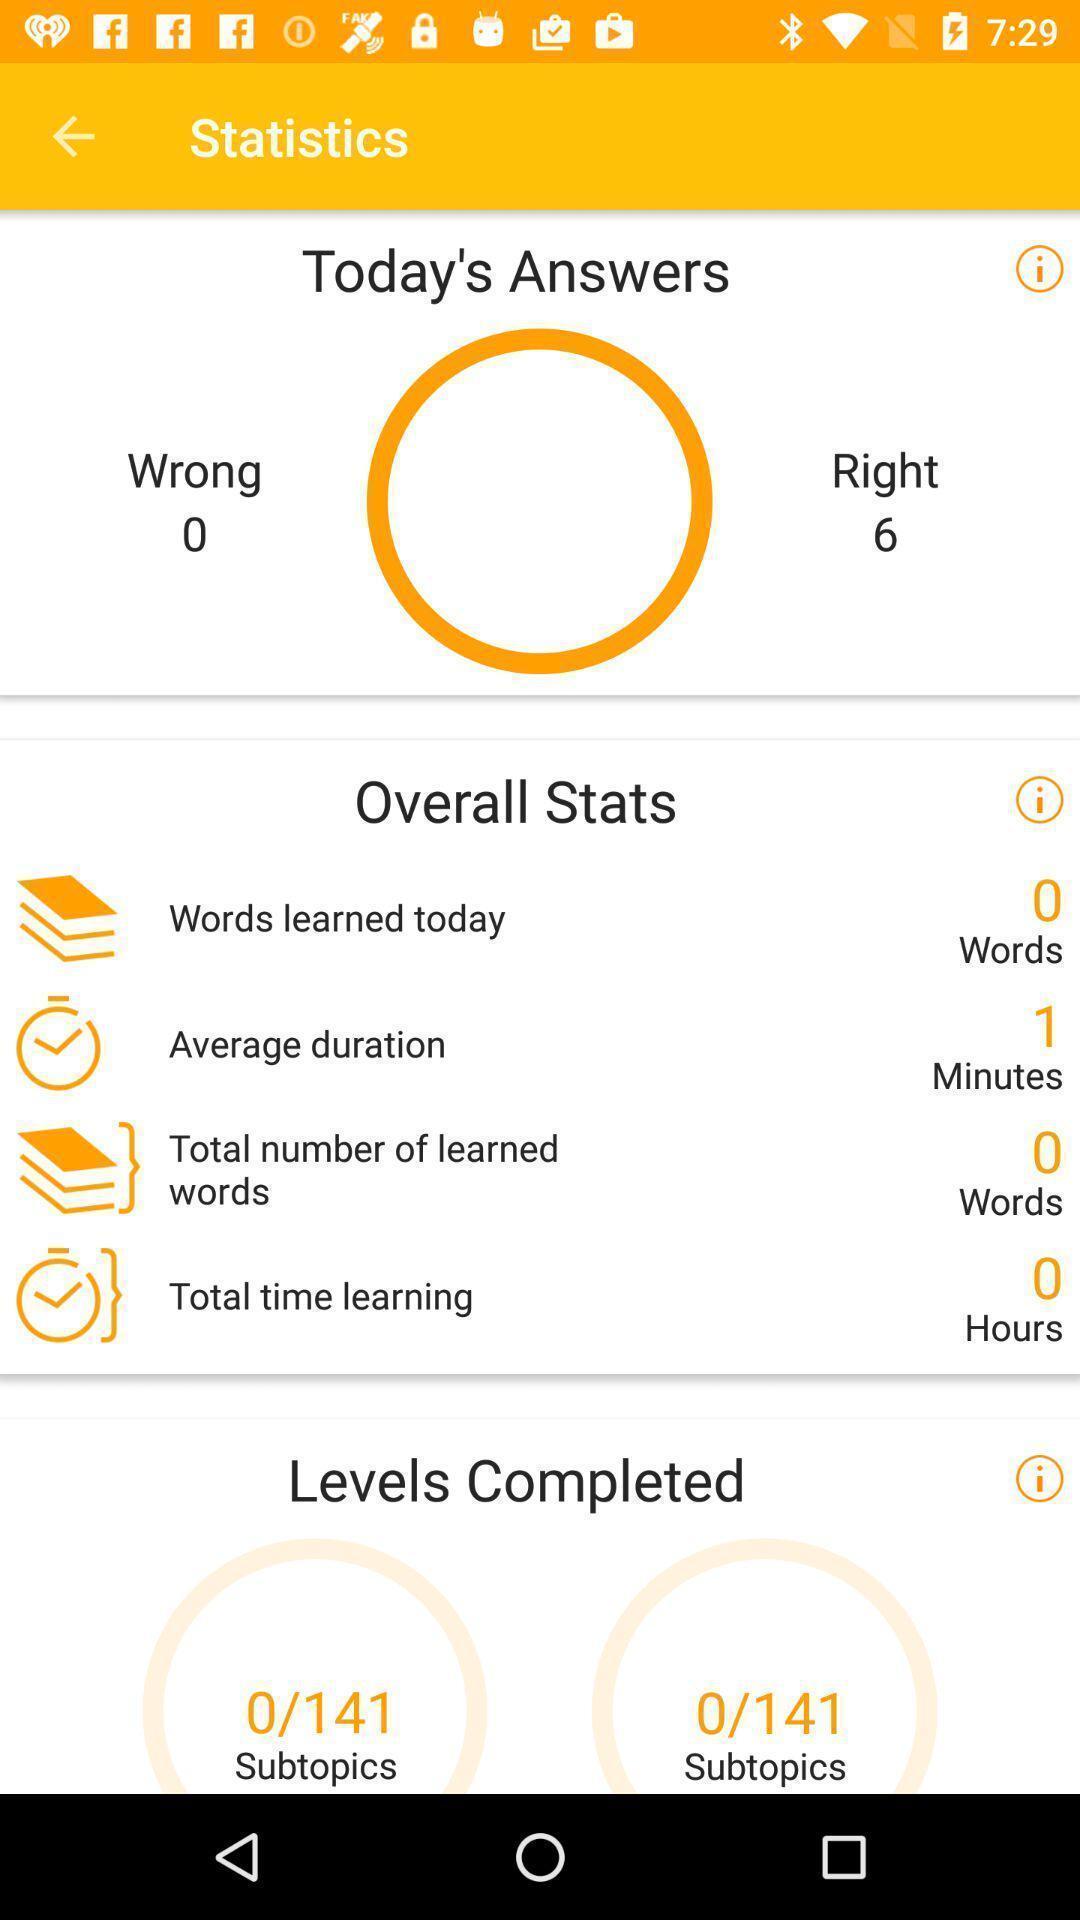Describe the key features of this screenshot. Statistics page of a language learning application. 